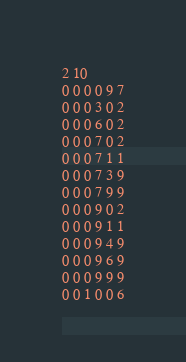Convert code to text. <code><loc_0><loc_0><loc_500><loc_500><_SQL_>2 10
0 0 0 0 9 7
0 0 0 3 0 2
0 0 0 6 0 2
0 0 0 7 0 2
0 0 0 7 1 1
0 0 0 7 3 9
0 0 0 7 9 9
0 0 0 9 0 2
0 0 0 9 1 1
0 0 0 9 4 9
0 0 0 9 6 9
0 0 0 9 9 9
0 0 1 0 0 6</code> 